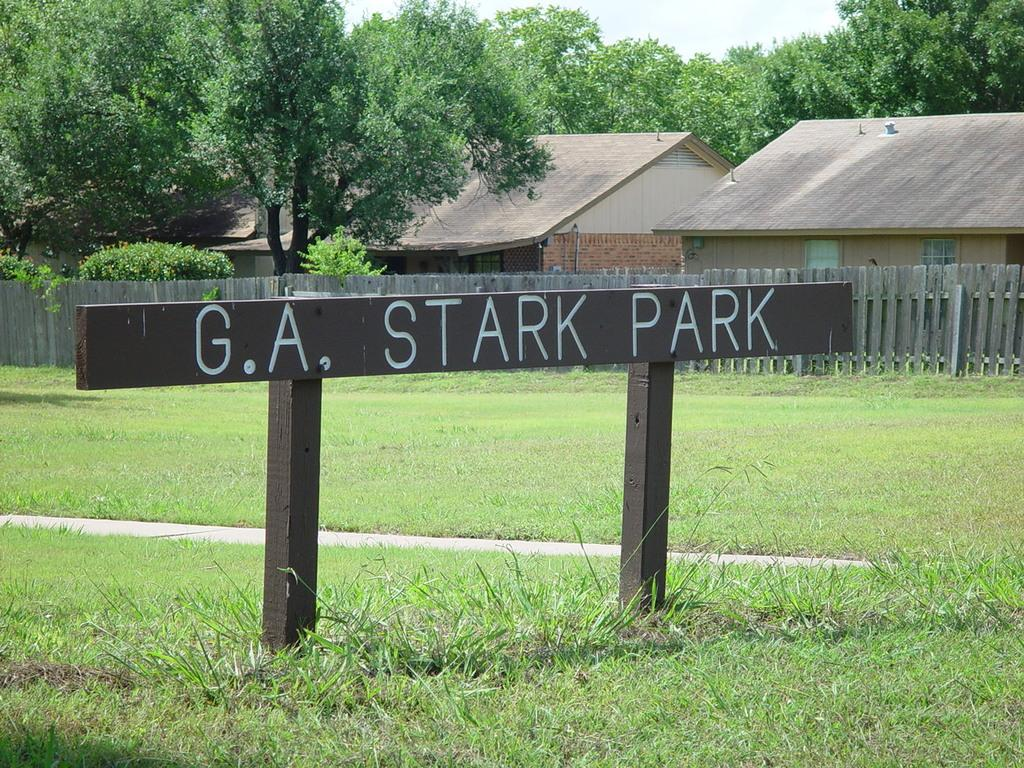What is located at the front of the image? There is a board in the front of the image. What type of vegetation is at the bottom of the image? There is grass at the bottom of the image. What can be seen in the background of the image? There are trees and houses in the background of the image. What is visible at the top of the image? The sky is visible at the top of the image. How many cars are parked at an angle in the image? There are no cars present in the image. What type of afterthought is depicted in the image? There is no afterthought depicted in the image; it features a board, grass, trees, houses, and the sky. 